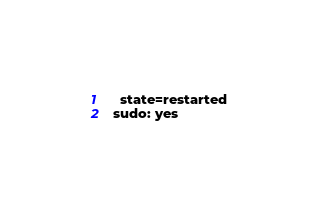Convert code to text. <code><loc_0><loc_0><loc_500><loc_500><_YAML_>    state=restarted
  sudo: yes
</code> 